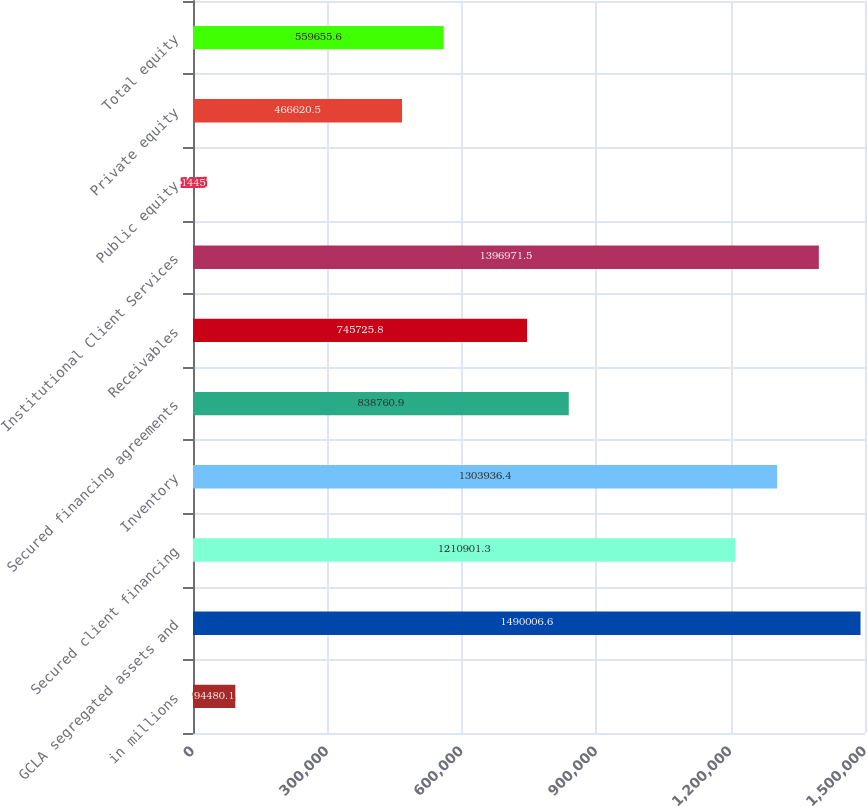Convert chart to OTSL. <chart><loc_0><loc_0><loc_500><loc_500><bar_chart><fcel>in millions<fcel>GCLA segregated assets and<fcel>Secured client financing<fcel>Inventory<fcel>Secured financing agreements<fcel>Receivables<fcel>Institutional Client Services<fcel>Public equity<fcel>Private equity<fcel>Total equity<nl><fcel>94480.1<fcel>1.49001e+06<fcel>1.2109e+06<fcel>1.30394e+06<fcel>838761<fcel>745726<fcel>1.39697e+06<fcel>1445<fcel>466620<fcel>559656<nl></chart> 